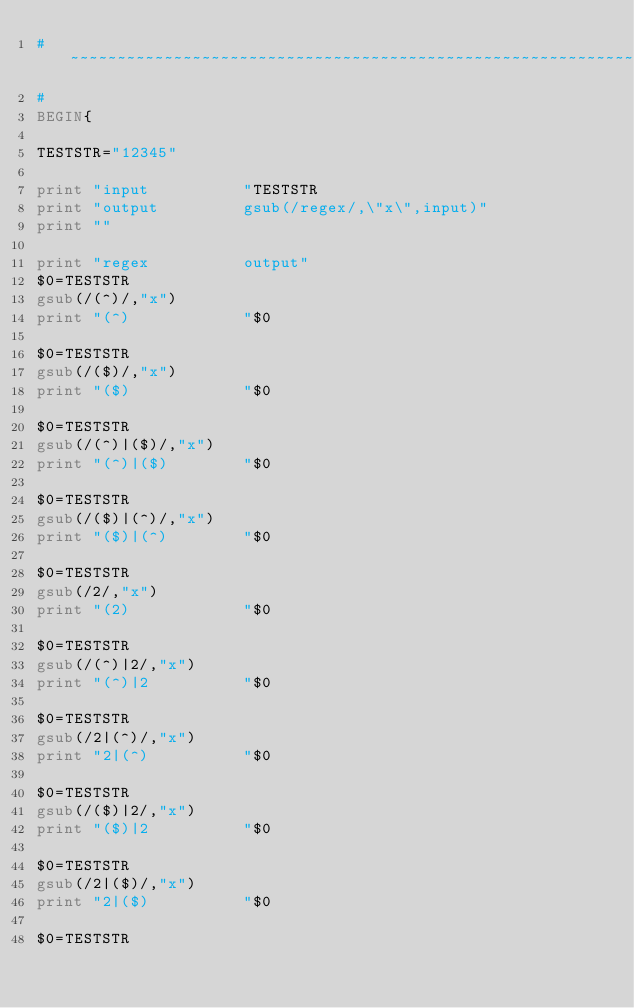<code> <loc_0><loc_0><loc_500><loc_500><_Awk_>#~~~~~~~~~~~~~~~~~~~~~~~~~~~~~~~~~~~~~~~~~~~~~~~~~~~~~~~~~~~~~~~~~~~~~~
#
BEGIN{

TESTSTR="12345"

print "input          "TESTSTR
print "output         gsub(/regex/,\"x\",input)"
print ""

print "regex          output"
$0=TESTSTR
gsub(/(^)/,"x")
print "(^)            "$0

$0=TESTSTR
gsub(/($)/,"x")
print "($)            "$0

$0=TESTSTR
gsub(/(^)|($)/,"x")
print "(^)|($)        "$0

$0=TESTSTR
gsub(/($)|(^)/,"x")
print "($)|(^)        "$0

$0=TESTSTR
gsub(/2/,"x")
print "(2)            "$0

$0=TESTSTR
gsub(/(^)|2/,"x")
print "(^)|2          "$0

$0=TESTSTR
gsub(/2|(^)/,"x")
print "2|(^)          "$0

$0=TESTSTR
gsub(/($)|2/,"x")
print "($)|2          "$0

$0=TESTSTR
gsub(/2|($)/,"x")
print "2|($)          "$0

$0=TESTSTR</code> 